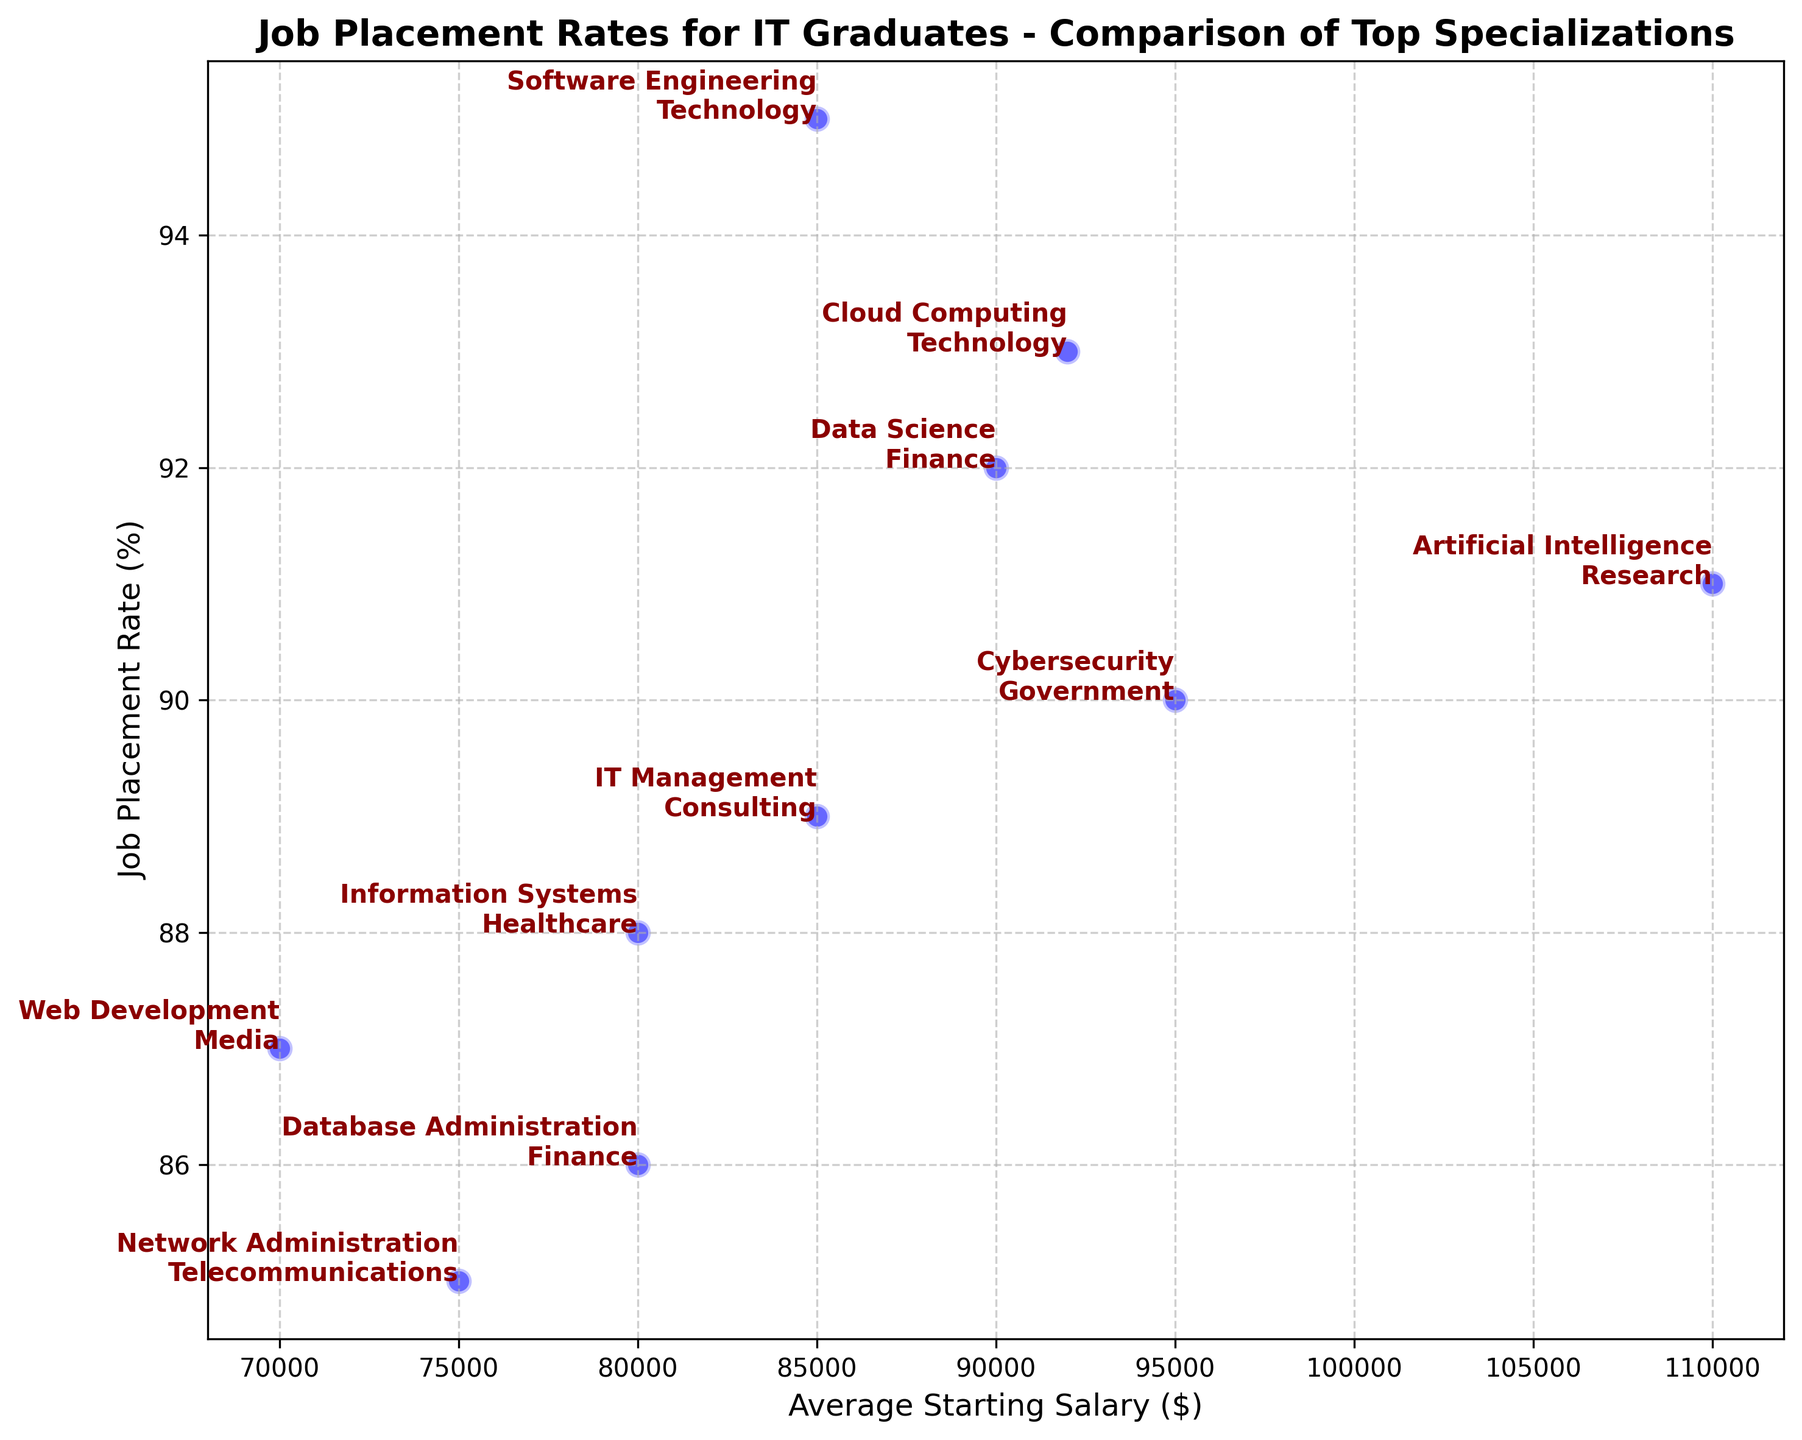What specialization has the highest job placement rate, and what is the accompanying average starting salary? The highest job placement rate is 95% for Software Engineering, and the associated average starting salary is $85,000.
Answer: Software Engineering, $85,000 Which specialization offers the highest average starting salary, and what is its job placement rate? Artificial Intelligence offers the highest average starting salary at $110,000, with a job placement rate of 91%.
Answer: Artificial Intelligence, 91% Between Cybersecurity and Data Science, which specialization has a higher job placement rate, and by how much? Cybersecurity has a job placement rate of 90%, while Data Science has 92%. The difference is 92% - 90% = 2%.
Answer: Data Science, by 2% What is the average job placement rate for the specializations in the Healthcare and Finance industries? Healthcare (Information Systems) has a job placement rate of 88%, and Finance (Data Science and Database Administration) has rates of 92% and 86%. The average is (88% + 92% + 86%)/3 ≈ 88.67%.
Answer: 88.67% How many specializations have an average starting salary lower than $80,000? The specializations with starting salaries lower than $80,000 are Network Administration ($75,000) and Web Development ($70,000).
Answer: 2 Which specialization in the Government industry has the highest job placement rate? Cybersecurity is in the Government industry and has a job placement rate of 90%.
Answer: Cybersecurity What is the difference between the highest and lowest job placement rates among specializations? The highest job placement rate is 95% (Software Engineering), and the lowest is 85% (Network Administration). The difference is 95% - 85% = 10%.
Answer: 10% Identify the specialization with the lowest job placement rate and describe its top hiring industry and average starting salary. Network Administration has the lowest job placement rate at 85%. Its top hiring industry is Telecommunications, with an average starting salary of $75,000.
Answer: Network Administration, Telecommunications, $75,000 Which specialization shows the second-highest average starting salary, and what is its job placement rate? Cloud Computing has the second-highest average starting salary at $92,000, with a job placement rate of 93%.
Answer: Cloud Computing, 93% How does the average starting salary for IT Management compare to Information Systems? IT Management has an average starting salary of $85,000, while Information Systems has $80,000. IT Management's salary is $85,000 - $80,000 = $5,000 higher.
Answer: IT Management, $5,000 higher 